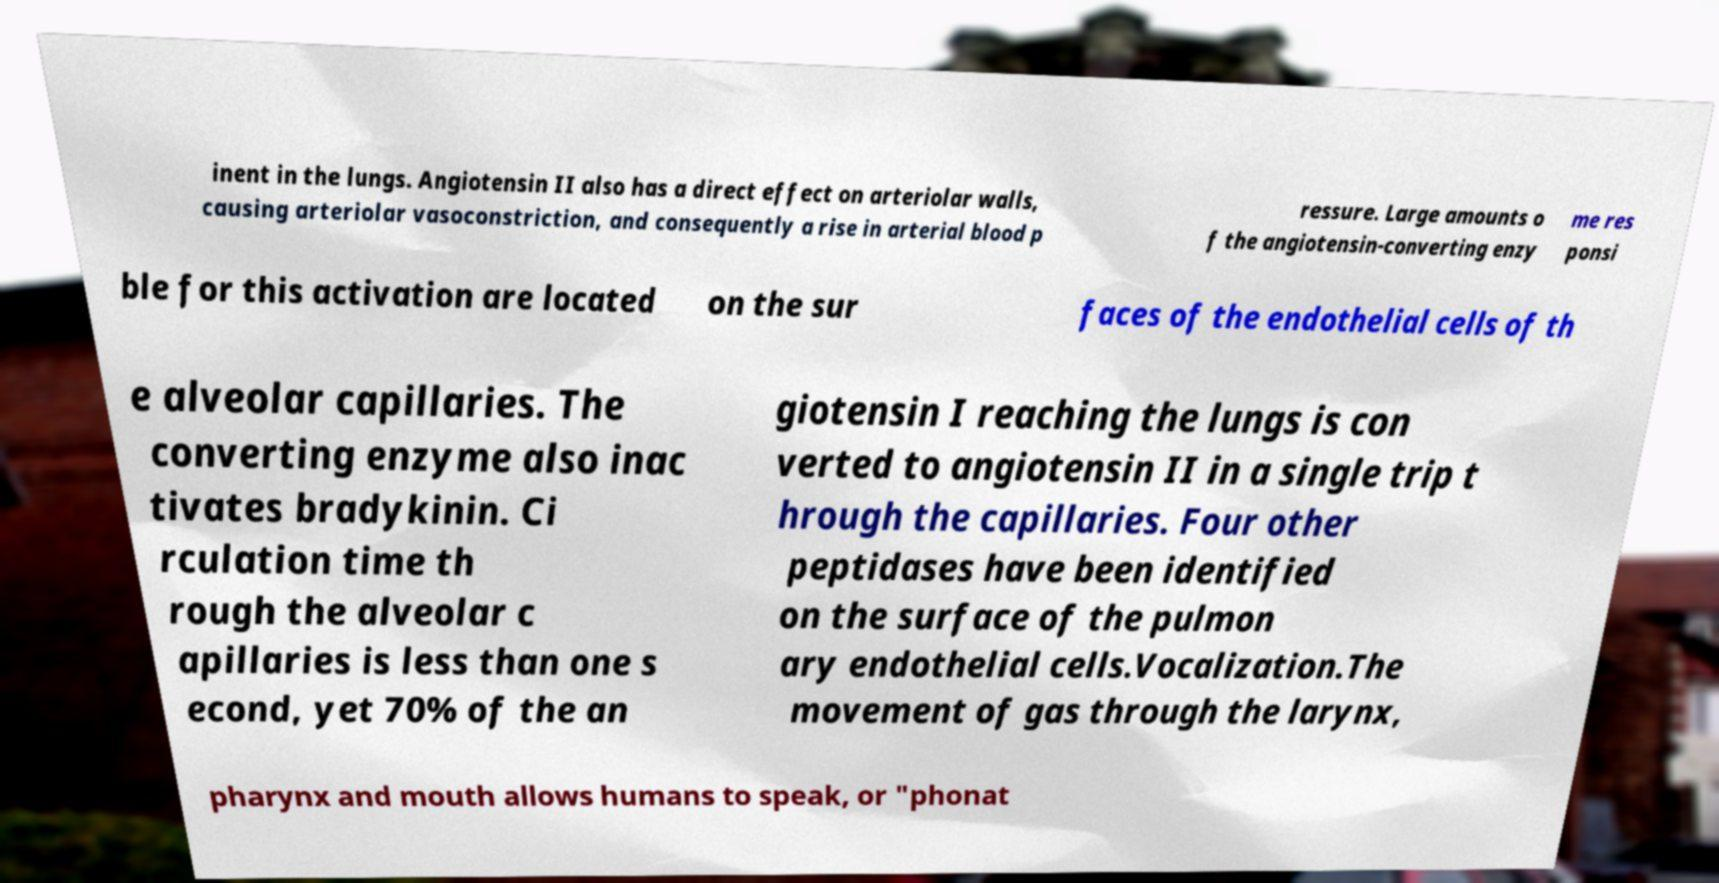What messages or text are displayed in this image? I need them in a readable, typed format. inent in the lungs. Angiotensin II also has a direct effect on arteriolar walls, causing arteriolar vasoconstriction, and consequently a rise in arterial blood p ressure. Large amounts o f the angiotensin-converting enzy me res ponsi ble for this activation are located on the sur faces of the endothelial cells of th e alveolar capillaries. The converting enzyme also inac tivates bradykinin. Ci rculation time th rough the alveolar c apillaries is less than one s econd, yet 70% of the an giotensin I reaching the lungs is con verted to angiotensin II in a single trip t hrough the capillaries. Four other peptidases have been identified on the surface of the pulmon ary endothelial cells.Vocalization.The movement of gas through the larynx, pharynx and mouth allows humans to speak, or "phonat 